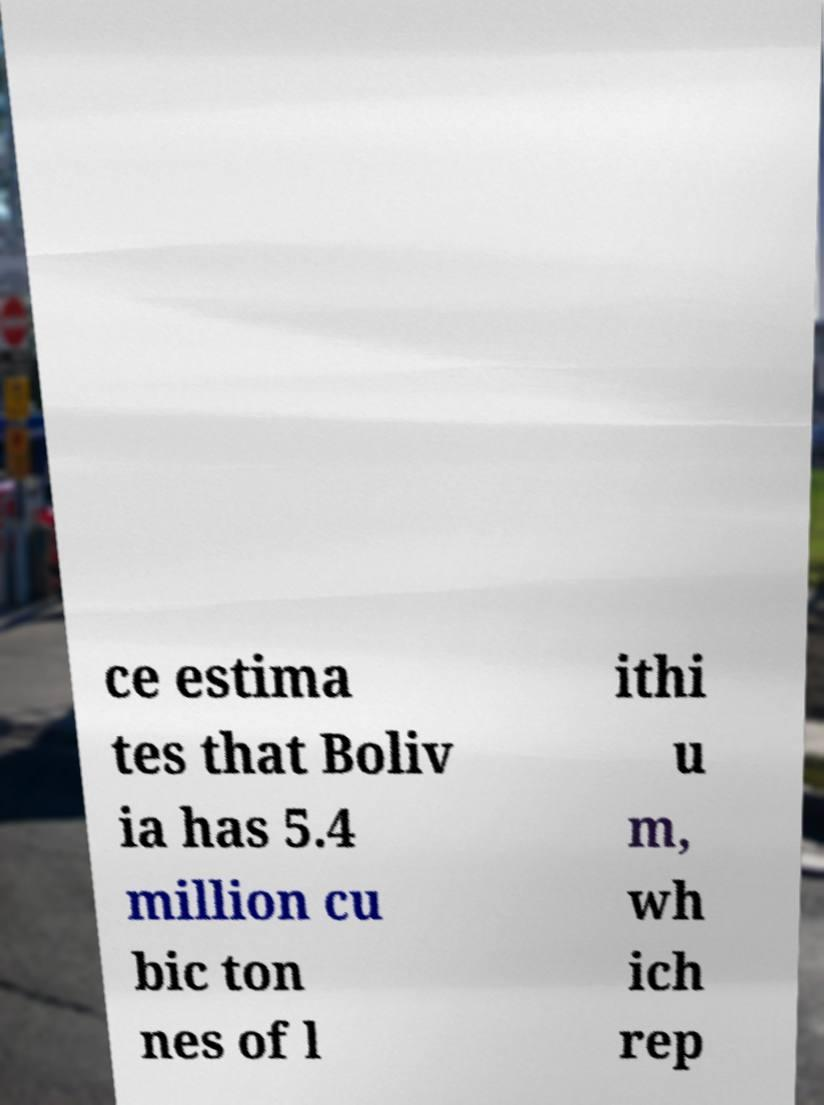Could you extract and type out the text from this image? ce estima tes that Boliv ia has 5.4 million cu bic ton nes of l ithi u m, wh ich rep 